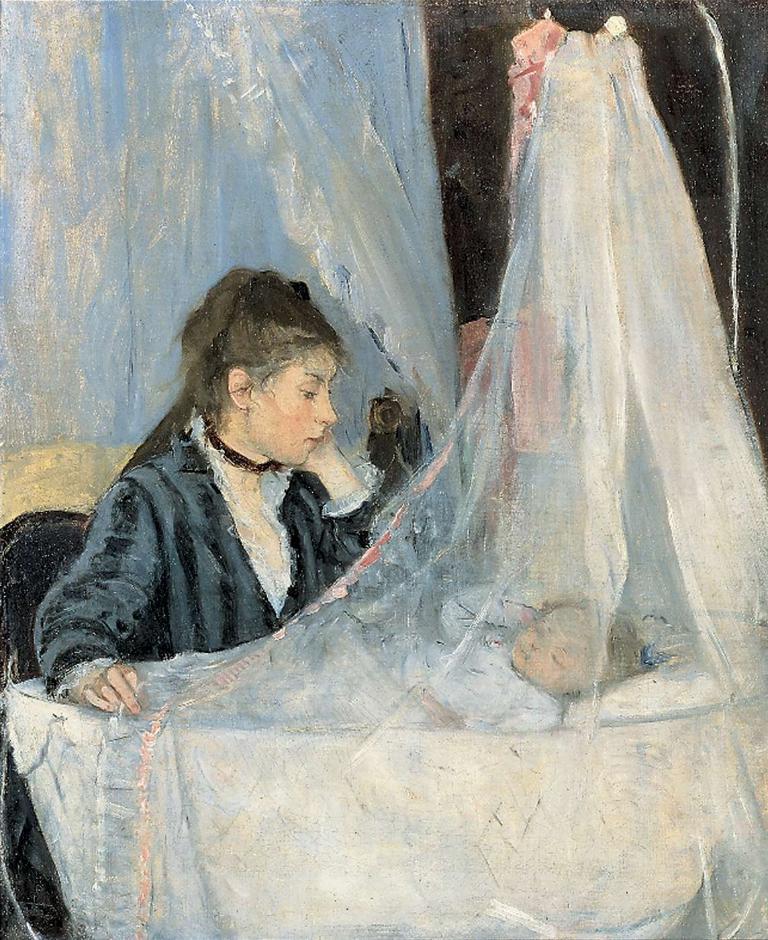In one or two sentences, can you explain what this image depicts? In this picture we can see the painting of a person and a baby is laying on a cradle. On the right side of the person there is a cloth. 